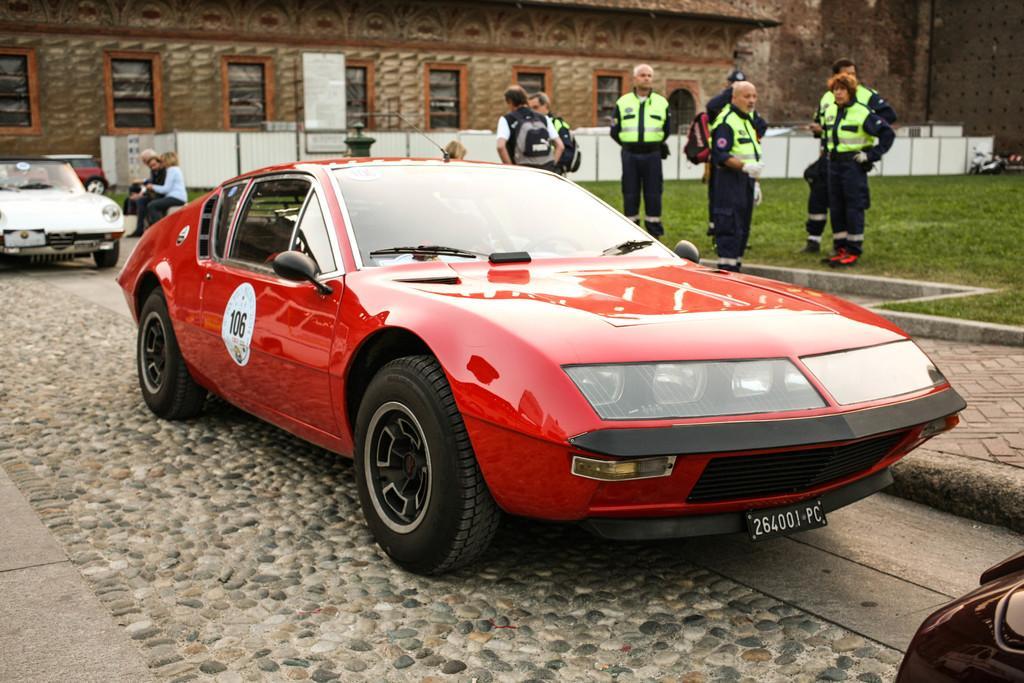Can you describe this image briefly? In this image we can see some vehicles and a group of people on the ground. We can also see grass, a fence, and a building with windows. 